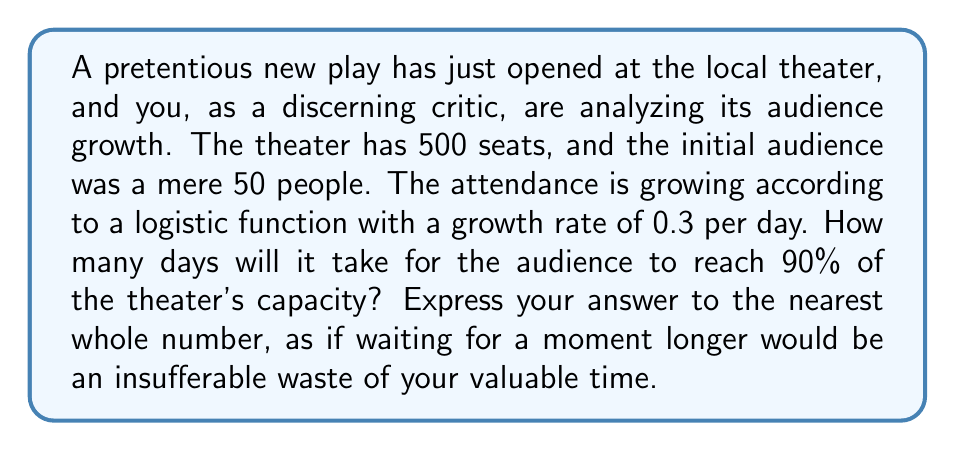What is the answer to this math problem? Let's approach this problem step-by-step, using the logistic growth function:

1) The logistic growth function is given by:

   $$P(t) = \frac{K}{1 + (\frac{K}{P_0} - 1)e^{-rt}}$$

   Where:
   $P(t)$ is the population (audience) at time $t$
   $K$ is the carrying capacity (theater capacity)
   $P_0$ is the initial population
   $r$ is the growth rate
   $t$ is time

2) We're given:
   $K = 500$ (theater capacity)
   $P_0 = 50$ (initial audience)
   $r = 0.3$ (growth rate per day)

3) We want to find $t$ when $P(t) = 0.9K = 450$

4) Substituting into the logistic equation:

   $$450 = \frac{500}{1 + (\frac{500}{50} - 1)e^{-0.3t}}$$

5) Simplifying:

   $$450 = \frac{500}{1 + 9e^{-0.3t}}$$

6) Solving for $t$:
   
   $$1 + 9e^{-0.3t} = \frac{500}{450} = \frac{10}{9}$$
   
   $$9e^{-0.3t} = \frac{1}{9}$$
   
   $$e^{-0.3t} = \frac{1}{81}$$
   
   $$-0.3t = \ln(\frac{1}{81}) = -\ln(81)$$
   
   $$t = \frac{\ln(81)}{0.3} \approx 14.63$$

7) Rounding to the nearest whole number:

   $t = 15$ days
Answer: 15 days 